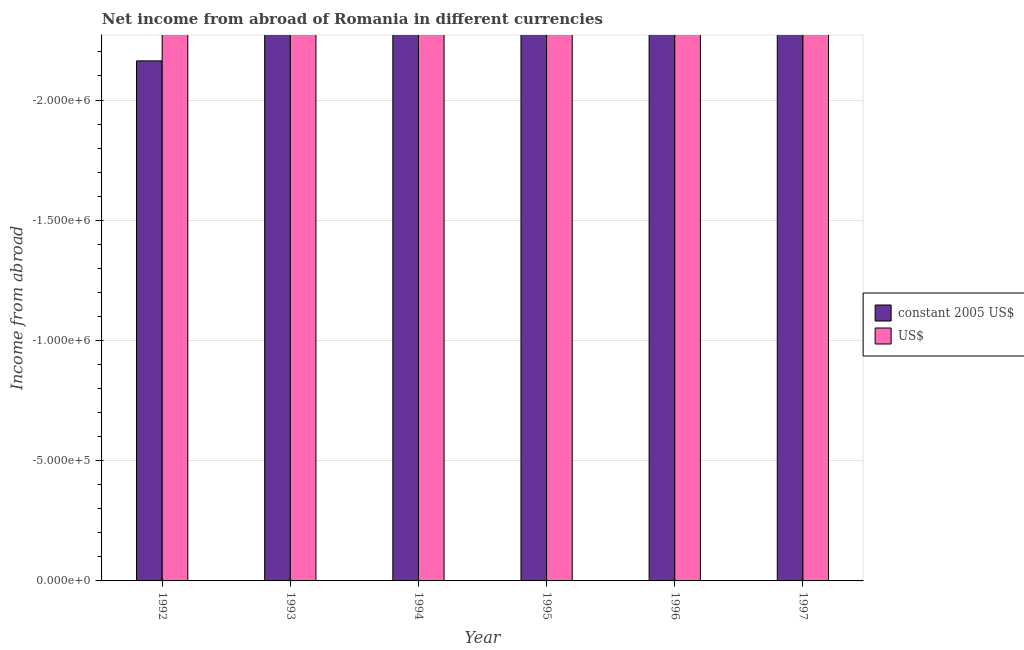Are the number of bars on each tick of the X-axis equal?
Provide a short and direct response. Yes. How many bars are there on the 5th tick from the right?
Give a very brief answer. 0. What is the label of the 5th group of bars from the left?
Ensure brevity in your answer.  1996. What is the income from abroad in constant 2005 us$ in 1995?
Your answer should be very brief. 0. What is the difference between the income from abroad in constant 2005 us$ in 1996 and the income from abroad in us$ in 1993?
Ensure brevity in your answer.  0. What is the average income from abroad in constant 2005 us$ per year?
Keep it short and to the point. 0. In how many years, is the income from abroad in constant 2005 us$ greater than -1400000 units?
Offer a very short reply. 0. How many bars are there?
Offer a very short reply. 0. How many years are there in the graph?
Offer a terse response. 6. What is the difference between two consecutive major ticks on the Y-axis?
Give a very brief answer. 5.00e+05. Are the values on the major ticks of Y-axis written in scientific E-notation?
Your response must be concise. Yes. Does the graph contain any zero values?
Keep it short and to the point. Yes. Does the graph contain grids?
Ensure brevity in your answer.  Yes. What is the title of the graph?
Ensure brevity in your answer.  Net income from abroad of Romania in different currencies. What is the label or title of the X-axis?
Offer a very short reply. Year. What is the label or title of the Y-axis?
Your response must be concise. Income from abroad. What is the Income from abroad in constant 2005 US$ in 1992?
Give a very brief answer. 0. What is the Income from abroad in US$ in 1992?
Offer a very short reply. 0. What is the Income from abroad in constant 2005 US$ in 1994?
Keep it short and to the point. 0. What is the Income from abroad of US$ in 1994?
Make the answer very short. 0. What is the Income from abroad of US$ in 1996?
Offer a terse response. 0. What is the Income from abroad of constant 2005 US$ in 1997?
Your answer should be compact. 0. What is the total Income from abroad of constant 2005 US$ in the graph?
Ensure brevity in your answer.  0. What is the average Income from abroad in constant 2005 US$ per year?
Ensure brevity in your answer.  0. What is the average Income from abroad in US$ per year?
Offer a very short reply. 0. 